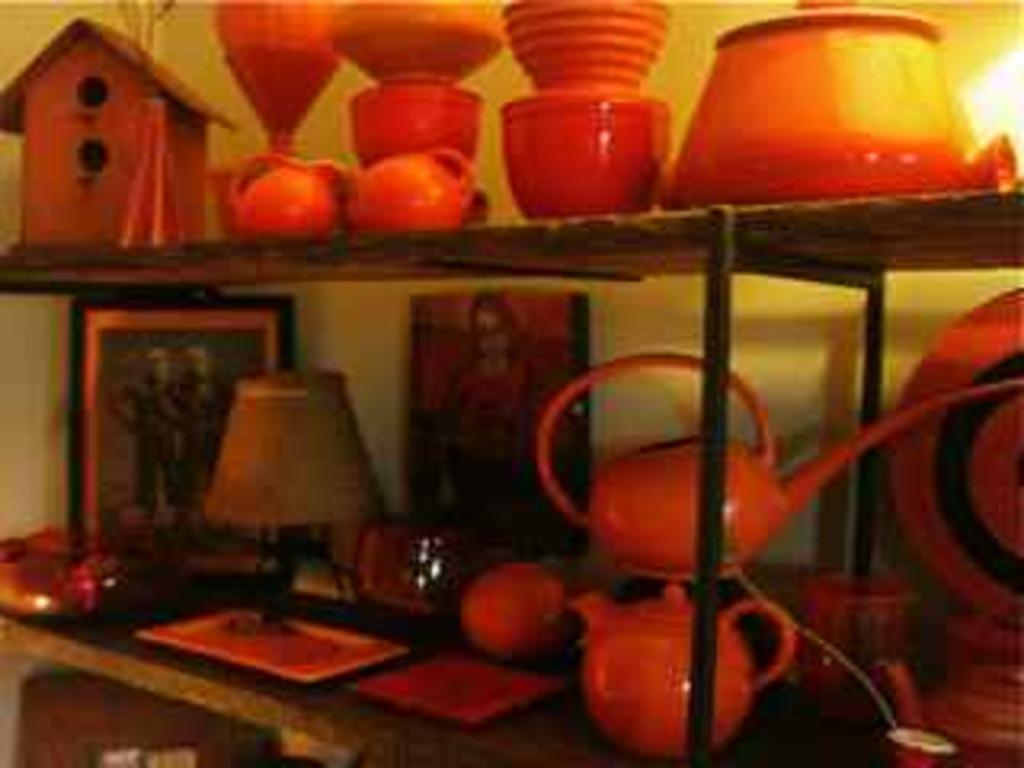Please provide a concise description of this image. This is a blurred image in which I can see shelves with objects like teapots, lamps, wall, painting, a hut, cups, mugs, pots and other objects. 